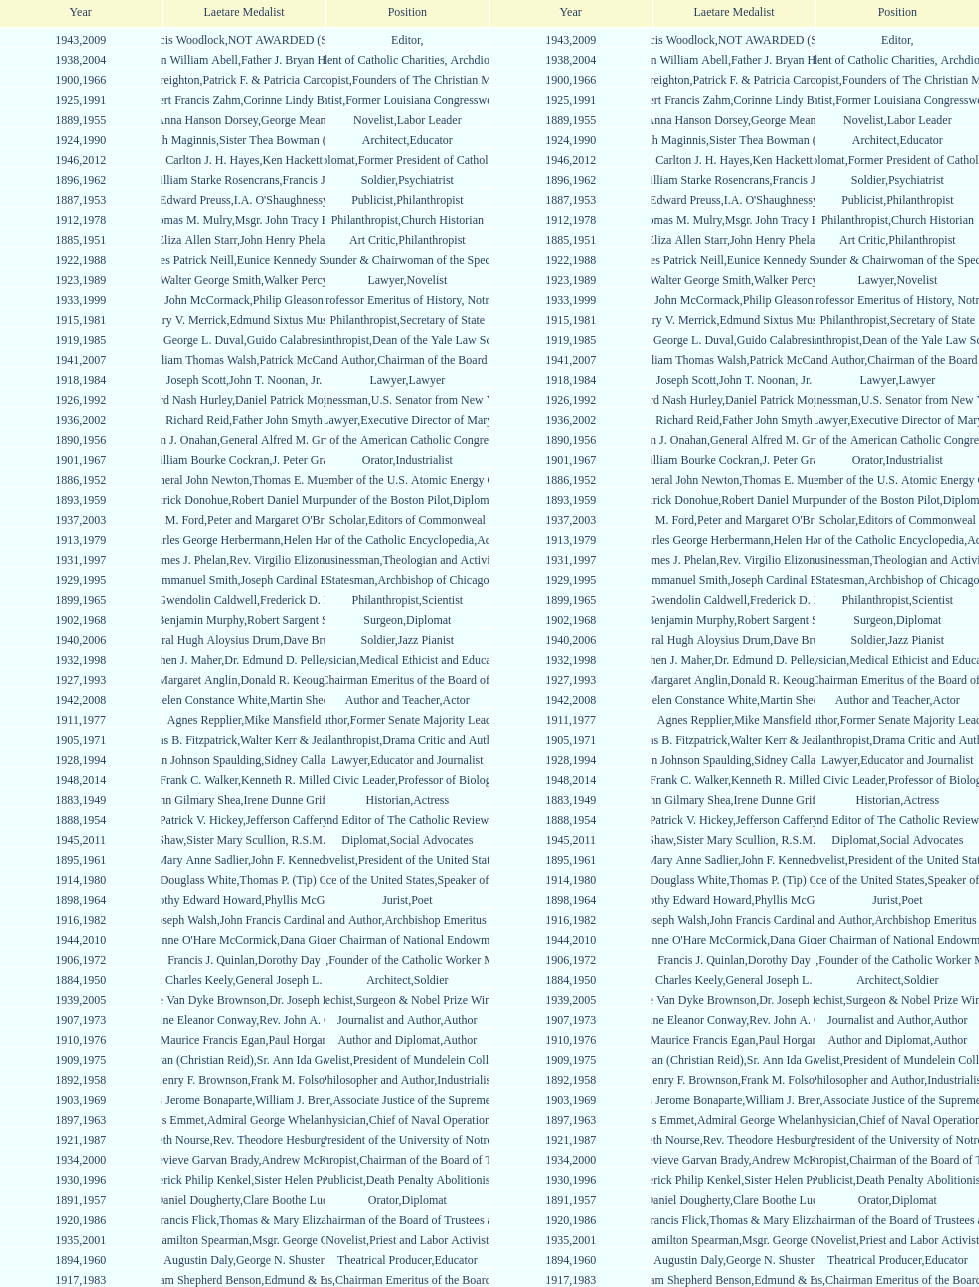How many are or were journalists? 5. 